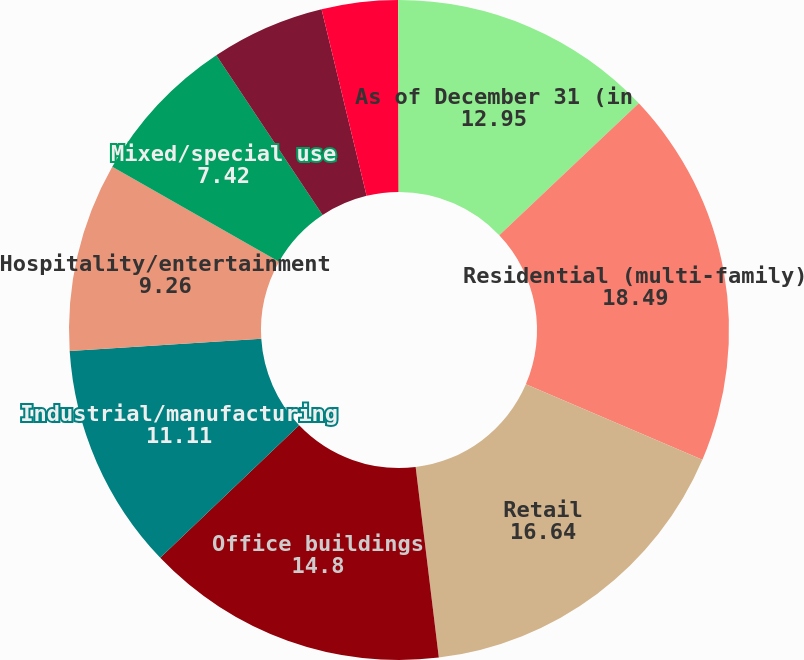<chart> <loc_0><loc_0><loc_500><loc_500><pie_chart><fcel>As of December 31 (in<fcel>Residential (multi-family)<fcel>Retail<fcel>Office buildings<fcel>Industrial/manufacturing<fcel>Hospitality/entertainment<fcel>Mixed/special use<fcel>Self-storage<fcel>Land<fcel>Health care<nl><fcel>12.95%<fcel>18.49%<fcel>16.64%<fcel>14.8%<fcel>11.11%<fcel>9.26%<fcel>7.42%<fcel>5.57%<fcel>3.73%<fcel>0.04%<nl></chart> 